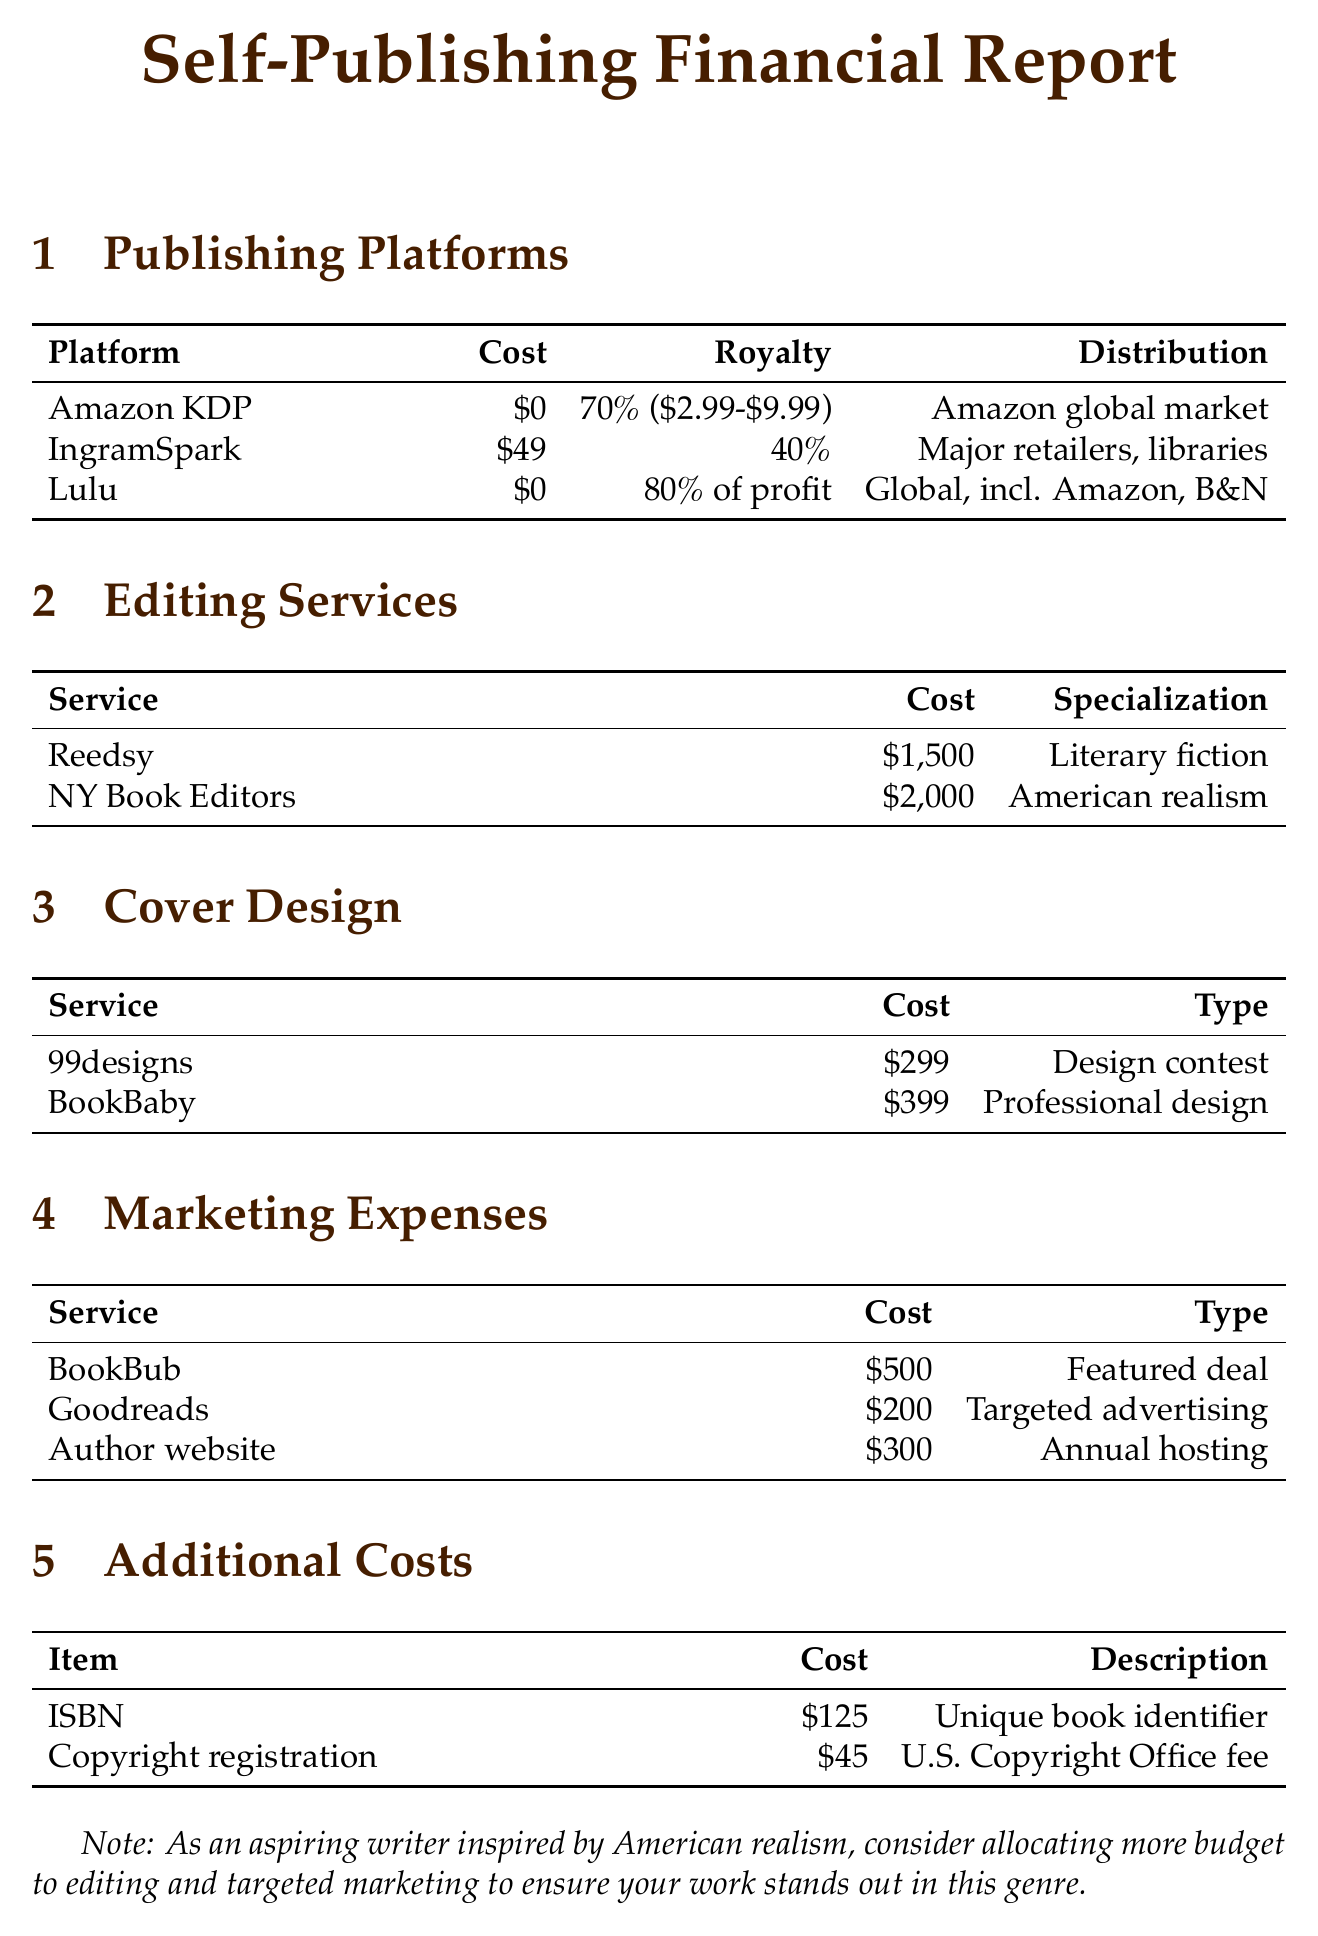what is the publishing cost for Amazon Kindle Direct Publishing? The publishing cost for Amazon Kindle Direct Publishing is listed in the "Publishing Platforms" section of the document.
Answer: 0 what is the royalty rate for IngramSpark? The royalty rate for IngramSpark can be found in the "Publishing Platforms" section and indicates how much the author earns from sales.
Answer: 40% of list price what is the average cost of editing services from NY Book Editors? The average cost of editing services is specified in the "Editing Services" section, indicating the cost for this specific service.
Answer: 2000 what type of service does BookBub provide? The type of service offered by BookBub is detailed in the "Marketing Expenses" section, specifically mentioning the nature of their promotional activities.
Answer: Featured deal how much does it cost to register a copyright? The cost for copyright registration is specified in the "Additional Costs" section, which outlines the financial requirements for legal protection of literary works.
Answer: 45 which self-publishing platform offers global distribution including Amazon and Barnes & Noble? This information is detailed in the "Publishing Platforms" section and highlights the broad reach of a specific service.
Answer: Lulu which editing service specializes in American realism? The specialization of editing services is documented in the "Editing Services" section and identifies a specific focus area of expertise.
Answer: NY Book Editors what is the average cost for a professional cover design service? The document lists the average cost of cover design services in the "Cover Design" section, specifically for professional offerings.
Answer: 399 what does the "Additional Costs" section list regarding ISBNs? The "Additional Costs" section provides specific details about ISBNs, including their necessity and costs associated.
Answer: 125 